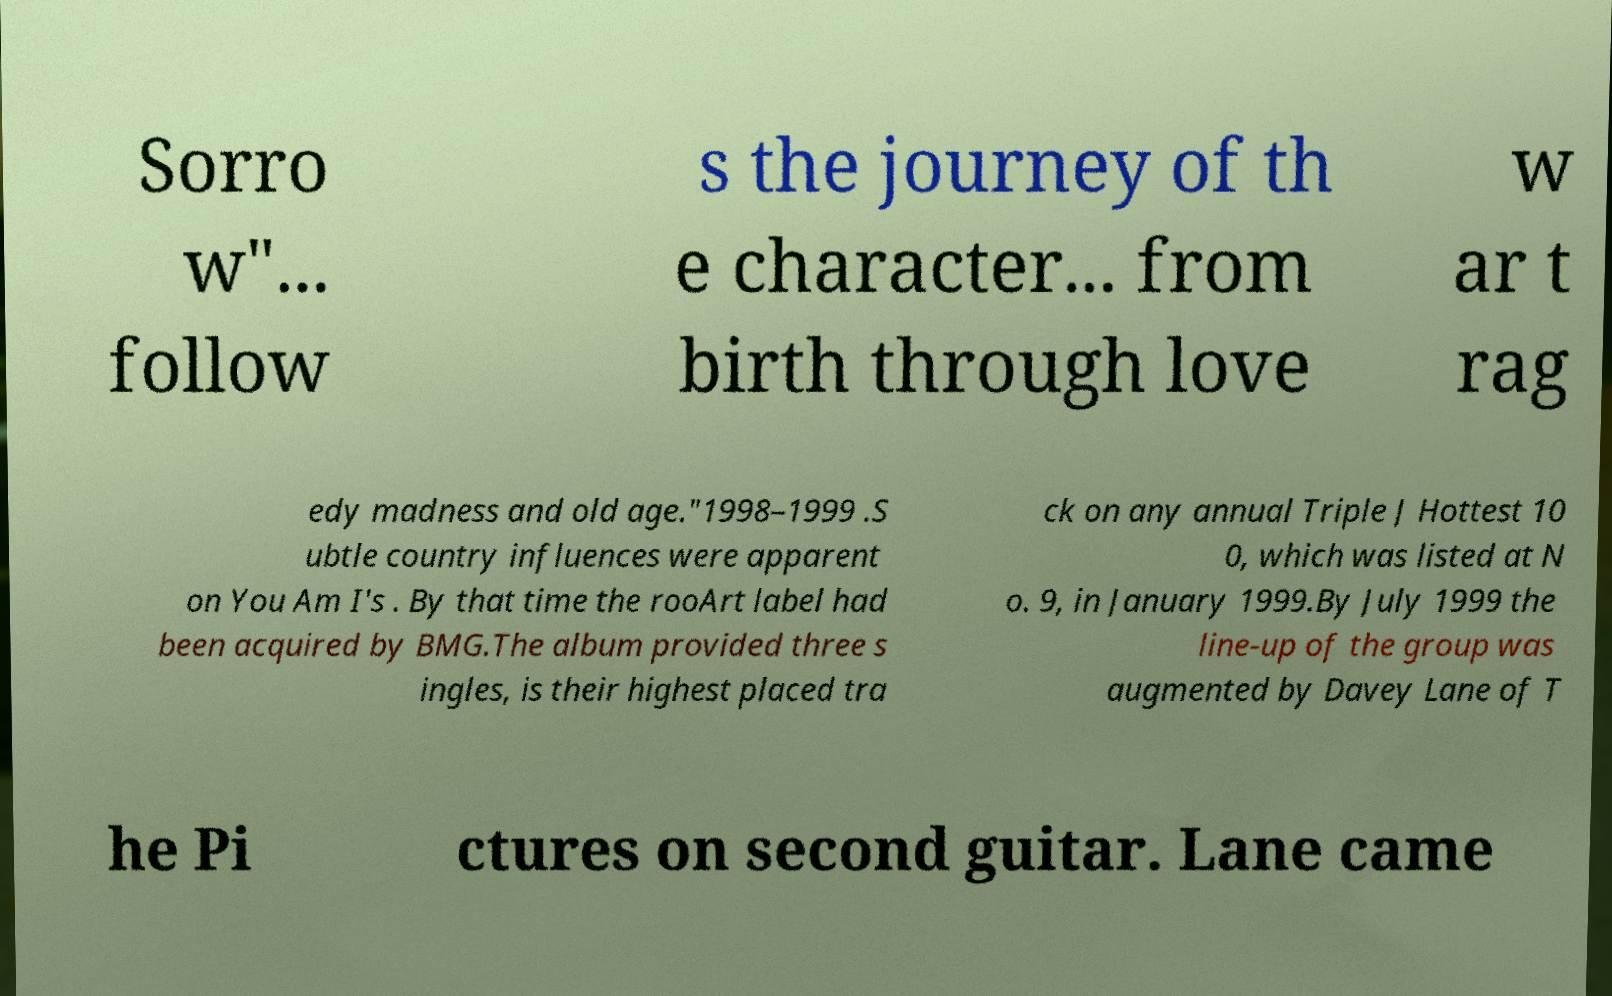What messages or text are displayed in this image? I need them in a readable, typed format. Sorro w"... follow s the journey of th e character... from birth through love w ar t rag edy madness and old age."1998–1999 .S ubtle country influences were apparent on You Am I's . By that time the rooArt label had been acquired by BMG.The album provided three s ingles, is their highest placed tra ck on any annual Triple J Hottest 10 0, which was listed at N o. 9, in January 1999.By July 1999 the line-up of the group was augmented by Davey Lane of T he Pi ctures on second guitar. Lane came 